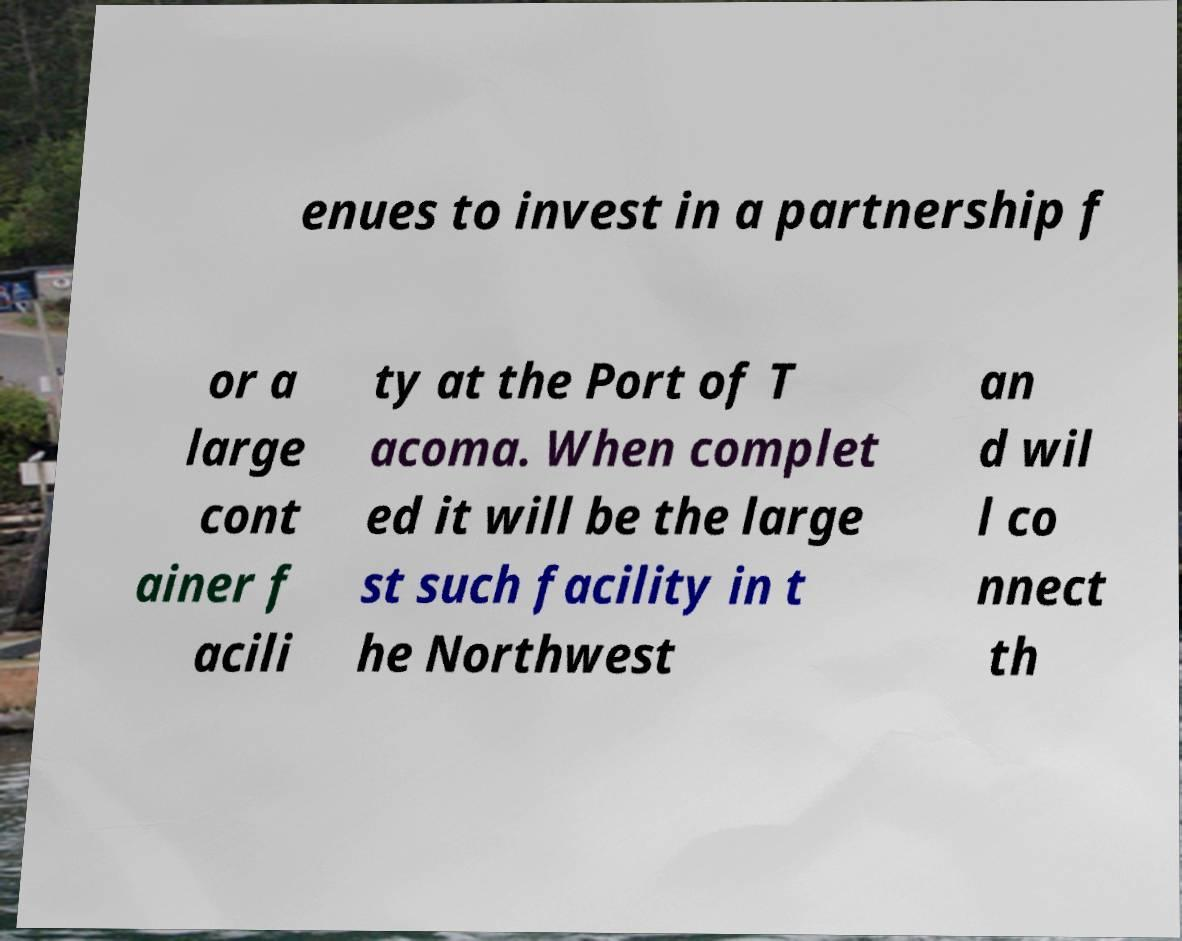Could you extract and type out the text from this image? enues to invest in a partnership f or a large cont ainer f acili ty at the Port of T acoma. When complet ed it will be the large st such facility in t he Northwest an d wil l co nnect th 